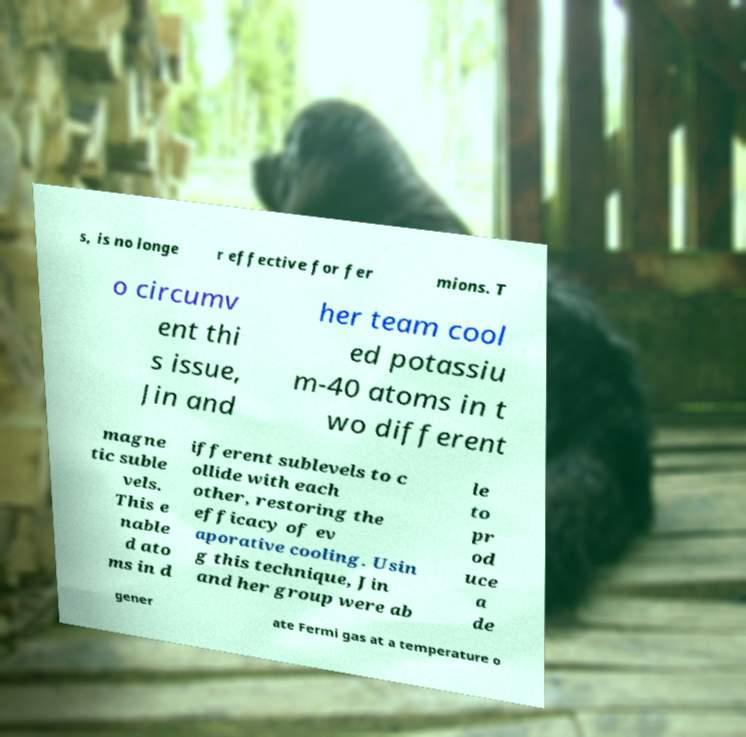Can you read and provide the text displayed in the image?This photo seems to have some interesting text. Can you extract and type it out for me? s, is no longe r effective for fer mions. T o circumv ent thi s issue, Jin and her team cool ed potassiu m-40 atoms in t wo different magne tic suble vels. This e nable d ato ms in d ifferent sublevels to c ollide with each other, restoring the efficacy of ev aporative cooling. Usin g this technique, Jin and her group were ab le to pr od uce a de gener ate Fermi gas at a temperature o 